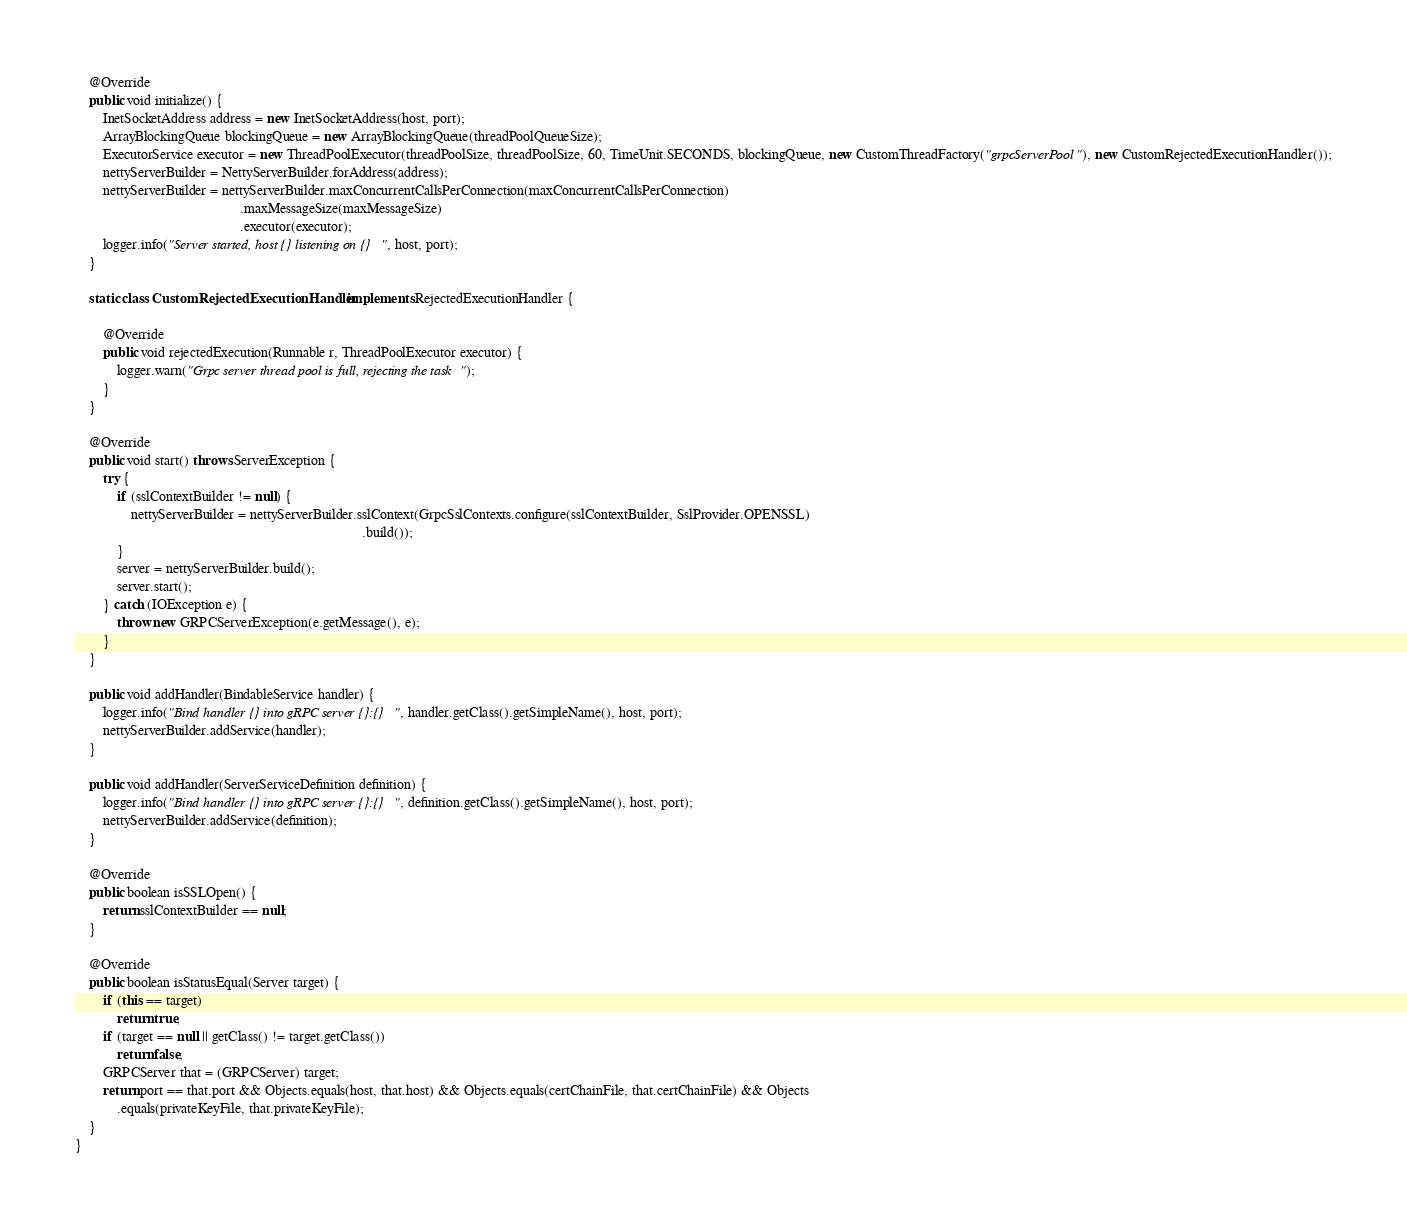<code> <loc_0><loc_0><loc_500><loc_500><_Java_>    @Override
    public void initialize() {
        InetSocketAddress address = new InetSocketAddress(host, port);
        ArrayBlockingQueue blockingQueue = new ArrayBlockingQueue(threadPoolQueueSize);
        ExecutorService executor = new ThreadPoolExecutor(threadPoolSize, threadPoolSize, 60, TimeUnit.SECONDS, blockingQueue, new CustomThreadFactory("grpcServerPool"), new CustomRejectedExecutionHandler());
        nettyServerBuilder = NettyServerBuilder.forAddress(address);
        nettyServerBuilder = nettyServerBuilder.maxConcurrentCallsPerConnection(maxConcurrentCallsPerConnection)
                                               .maxMessageSize(maxMessageSize)
                                               .executor(executor);
        logger.info("Server started, host {} listening on {}", host, port);
    }

    static class CustomRejectedExecutionHandler implements RejectedExecutionHandler {

        @Override
        public void rejectedExecution(Runnable r, ThreadPoolExecutor executor) {
            logger.warn("Grpc server thread pool is full, rejecting the task");
        }
    }

    @Override
    public void start() throws ServerException {
        try {
            if (sslContextBuilder != null) {
                nettyServerBuilder = nettyServerBuilder.sslContext(GrpcSslContexts.configure(sslContextBuilder, SslProvider.OPENSSL)
                                                                                  .build());
            }
            server = nettyServerBuilder.build();
            server.start();
        } catch (IOException e) {
            throw new GRPCServerException(e.getMessage(), e);
        }
    }

    public void addHandler(BindableService handler) {
        logger.info("Bind handler {} into gRPC server {}:{}", handler.getClass().getSimpleName(), host, port);
        nettyServerBuilder.addService(handler);
    }

    public void addHandler(ServerServiceDefinition definition) {
        logger.info("Bind handler {} into gRPC server {}:{}", definition.getClass().getSimpleName(), host, port);
        nettyServerBuilder.addService(definition);
    }

    @Override
    public boolean isSSLOpen() {
        return sslContextBuilder == null;
    }

    @Override
    public boolean isStatusEqual(Server target) {
        if (this == target)
            return true;
        if (target == null || getClass() != target.getClass())
            return false;
        GRPCServer that = (GRPCServer) target;
        return port == that.port && Objects.equals(host, that.host) && Objects.equals(certChainFile, that.certChainFile) && Objects
            .equals(privateKeyFile, that.privateKeyFile);
    }
}
</code> 